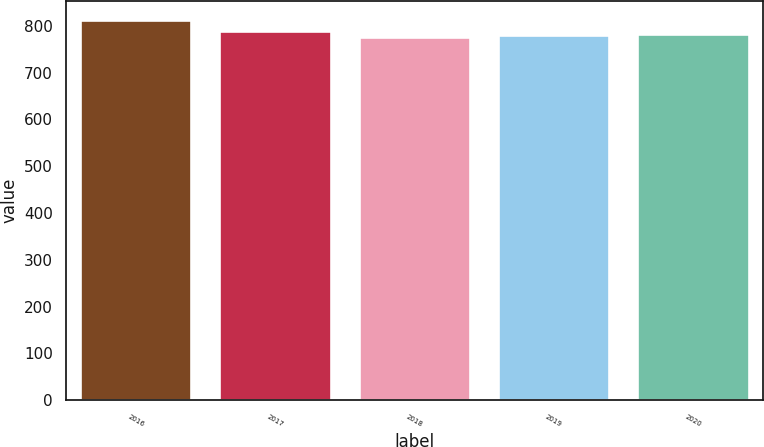<chart> <loc_0><loc_0><loc_500><loc_500><bar_chart><fcel>2016<fcel>2017<fcel>2018<fcel>2019<fcel>2020<nl><fcel>812<fcel>789<fcel>776<fcel>779.6<fcel>783.2<nl></chart> 